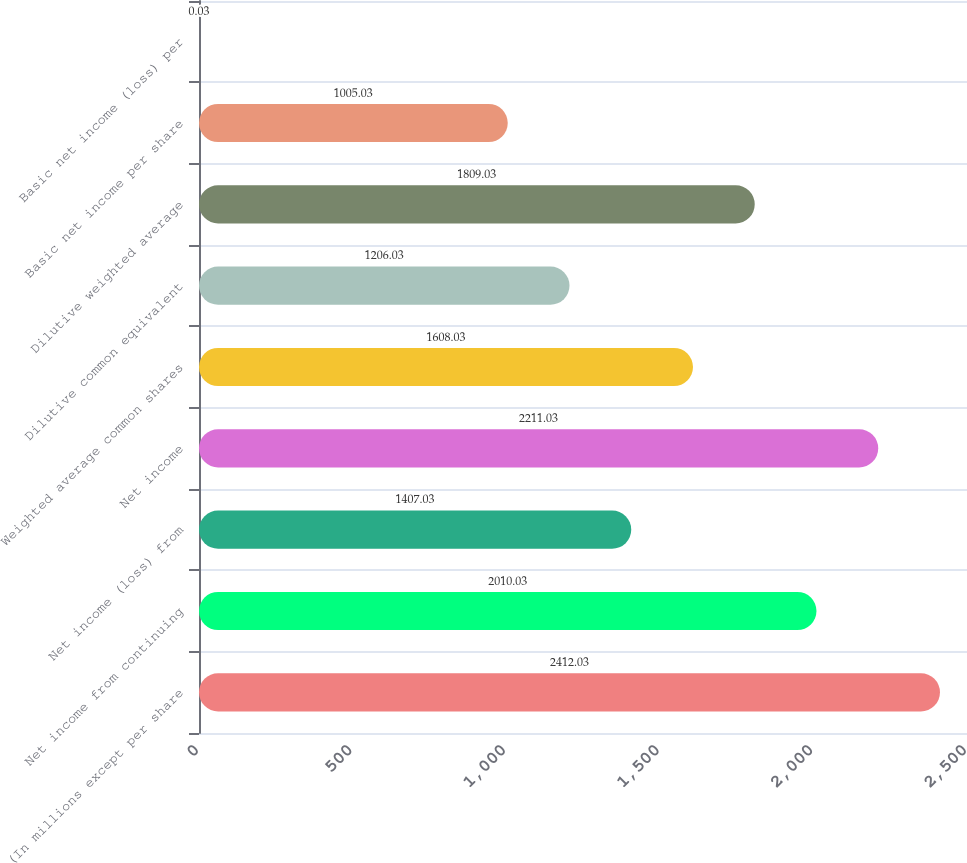<chart> <loc_0><loc_0><loc_500><loc_500><bar_chart><fcel>(In millions except per share<fcel>Net income from continuing<fcel>Net income (loss) from<fcel>Net income<fcel>Weighted average common shares<fcel>Dilutive common equivalent<fcel>Dilutive weighted average<fcel>Basic net income per share<fcel>Basic net income (loss) per<nl><fcel>2412.03<fcel>2010.03<fcel>1407.03<fcel>2211.03<fcel>1608.03<fcel>1206.03<fcel>1809.03<fcel>1005.03<fcel>0.03<nl></chart> 